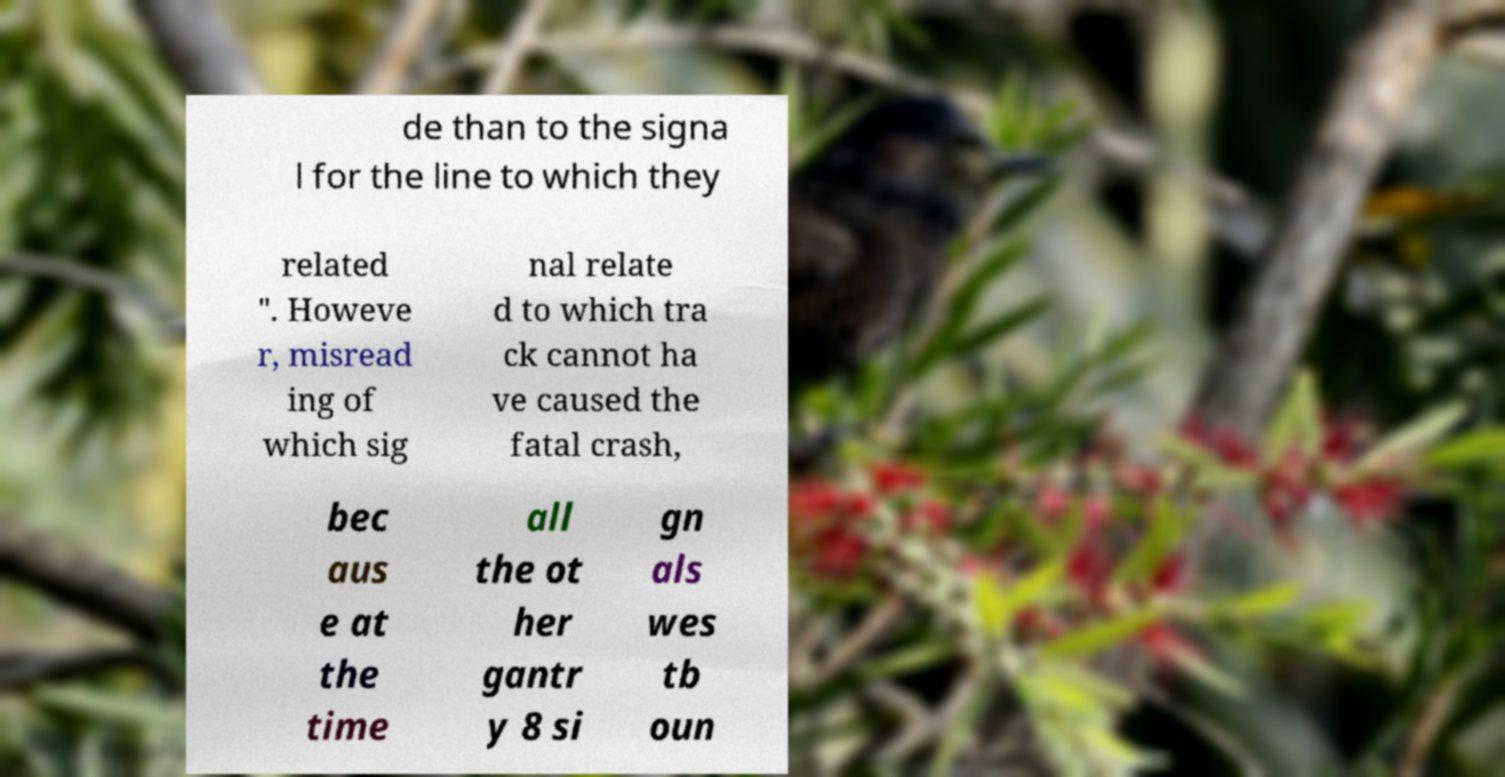For documentation purposes, I need the text within this image transcribed. Could you provide that? de than to the signa l for the line to which they related ". Howeve r, misread ing of which sig nal relate d to which tra ck cannot ha ve caused the fatal crash, bec aus e at the time all the ot her gantr y 8 si gn als wes tb oun 